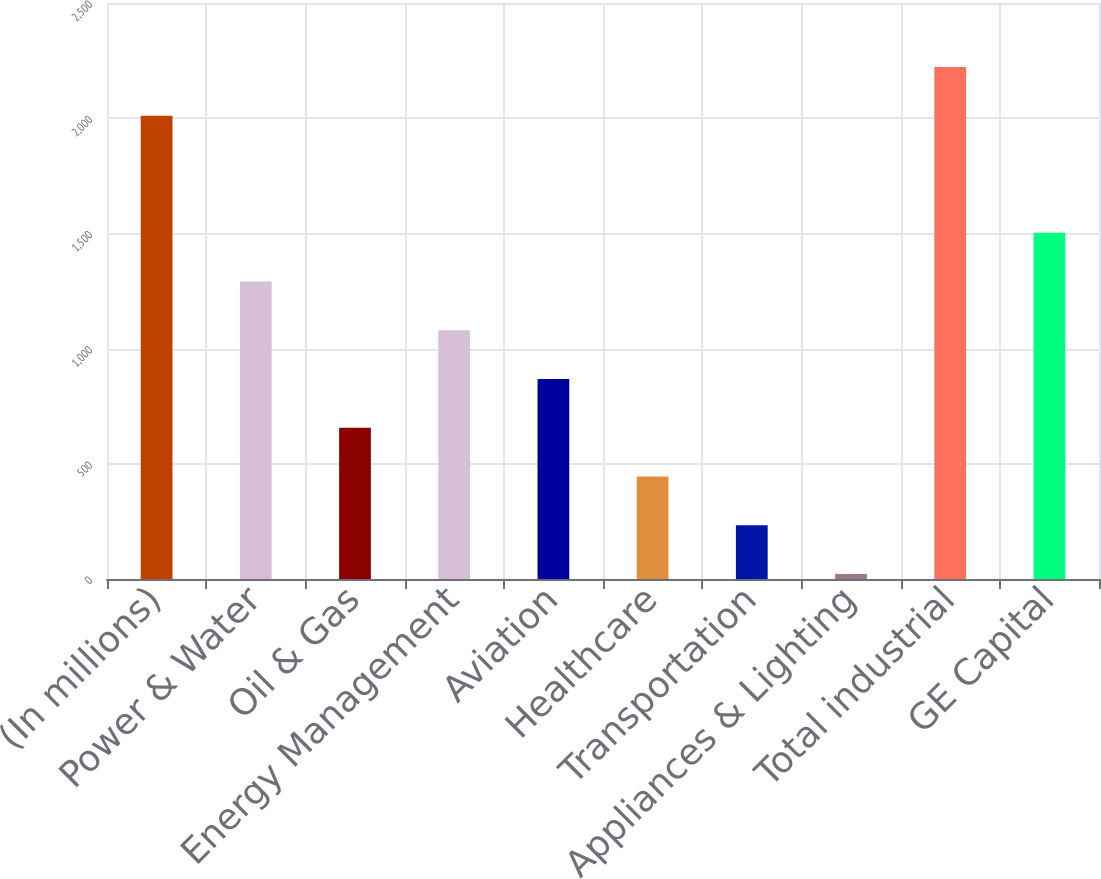Convert chart. <chart><loc_0><loc_0><loc_500><loc_500><bar_chart><fcel>(In millions)<fcel>Power & Water<fcel>Oil & Gas<fcel>Energy Management<fcel>Aviation<fcel>Healthcare<fcel>Transportation<fcel>Appliances & Lighting<fcel>Total industrial<fcel>GE Capital<nl><fcel>2011<fcel>1291<fcel>656.5<fcel>1079.5<fcel>868<fcel>445<fcel>233.5<fcel>22<fcel>2222.5<fcel>1502.5<nl></chart> 